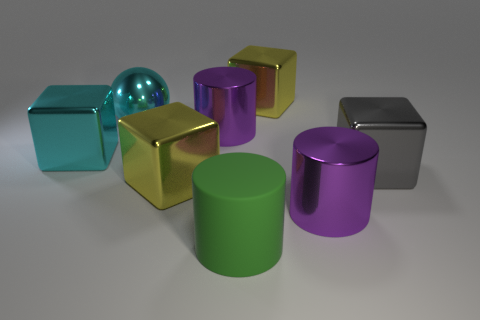Subtract all big metal cylinders. How many cylinders are left? 1 Add 2 gray metallic blocks. How many objects exist? 10 Subtract all cyan blocks. How many blocks are left? 3 Subtract 0 gray cylinders. How many objects are left? 8 Subtract all spheres. How many objects are left? 7 Subtract 3 cubes. How many cubes are left? 1 Subtract all cyan cylinders. Subtract all green balls. How many cylinders are left? 3 Subtract all gray balls. How many green blocks are left? 0 Subtract all blue cubes. Subtract all big yellow metallic blocks. How many objects are left? 6 Add 4 yellow metallic objects. How many yellow metallic objects are left? 6 